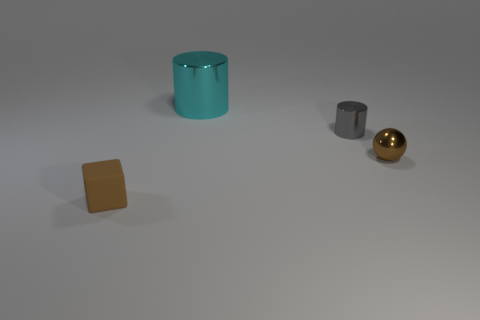Add 1 small brown shiny balls. How many objects exist? 5 Subtract all gray cylinders. How many cylinders are left? 1 Subtract all blocks. How many objects are left? 3 Subtract 1 blocks. How many blocks are left? 0 Add 3 large cyan cylinders. How many large cyan cylinders exist? 4 Subtract 0 cyan cubes. How many objects are left? 4 Subtract all cyan balls. Subtract all gray cylinders. How many balls are left? 1 Subtract all red cubes. How many cyan cylinders are left? 1 Subtract all small gray cylinders. Subtract all large blue cylinders. How many objects are left? 3 Add 3 tiny gray metal cylinders. How many tiny gray metal cylinders are left? 4 